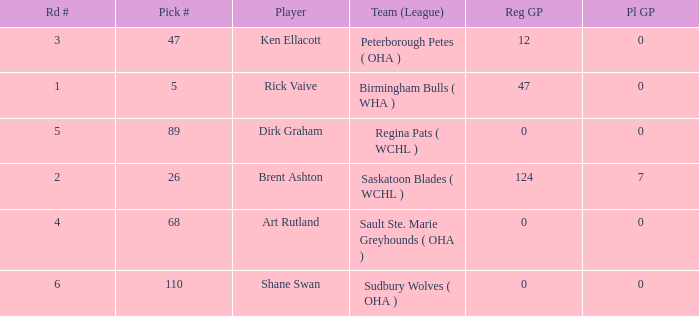How many rounds exist for picks under 5? 0.0. 